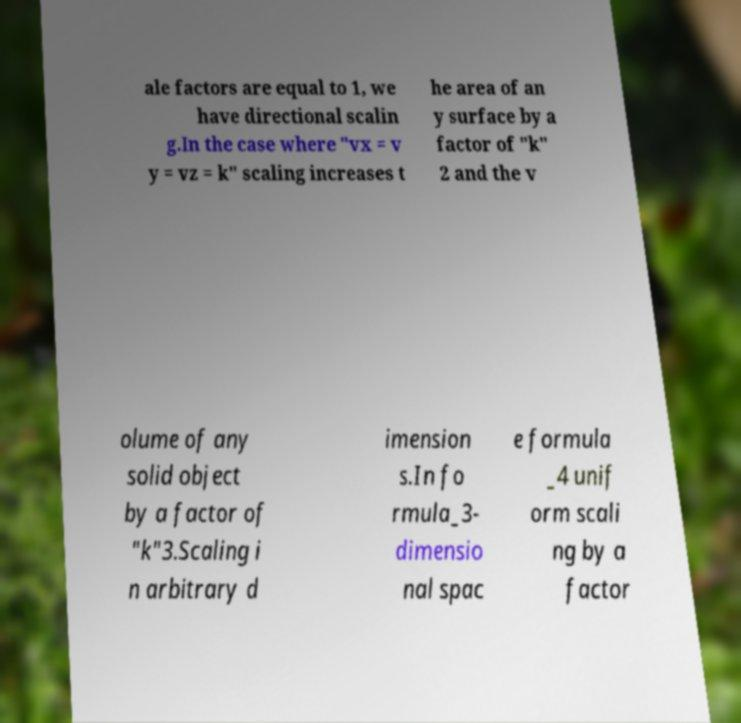Please read and relay the text visible in this image. What does it say? ale factors are equal to 1, we have directional scalin g.In the case where "vx = v y = vz = k" scaling increases t he area of an y surface by a factor of "k" 2 and the v olume of any solid object by a factor of "k"3.Scaling i n arbitrary d imension s.In fo rmula_3- dimensio nal spac e formula _4 unif orm scali ng by a factor 